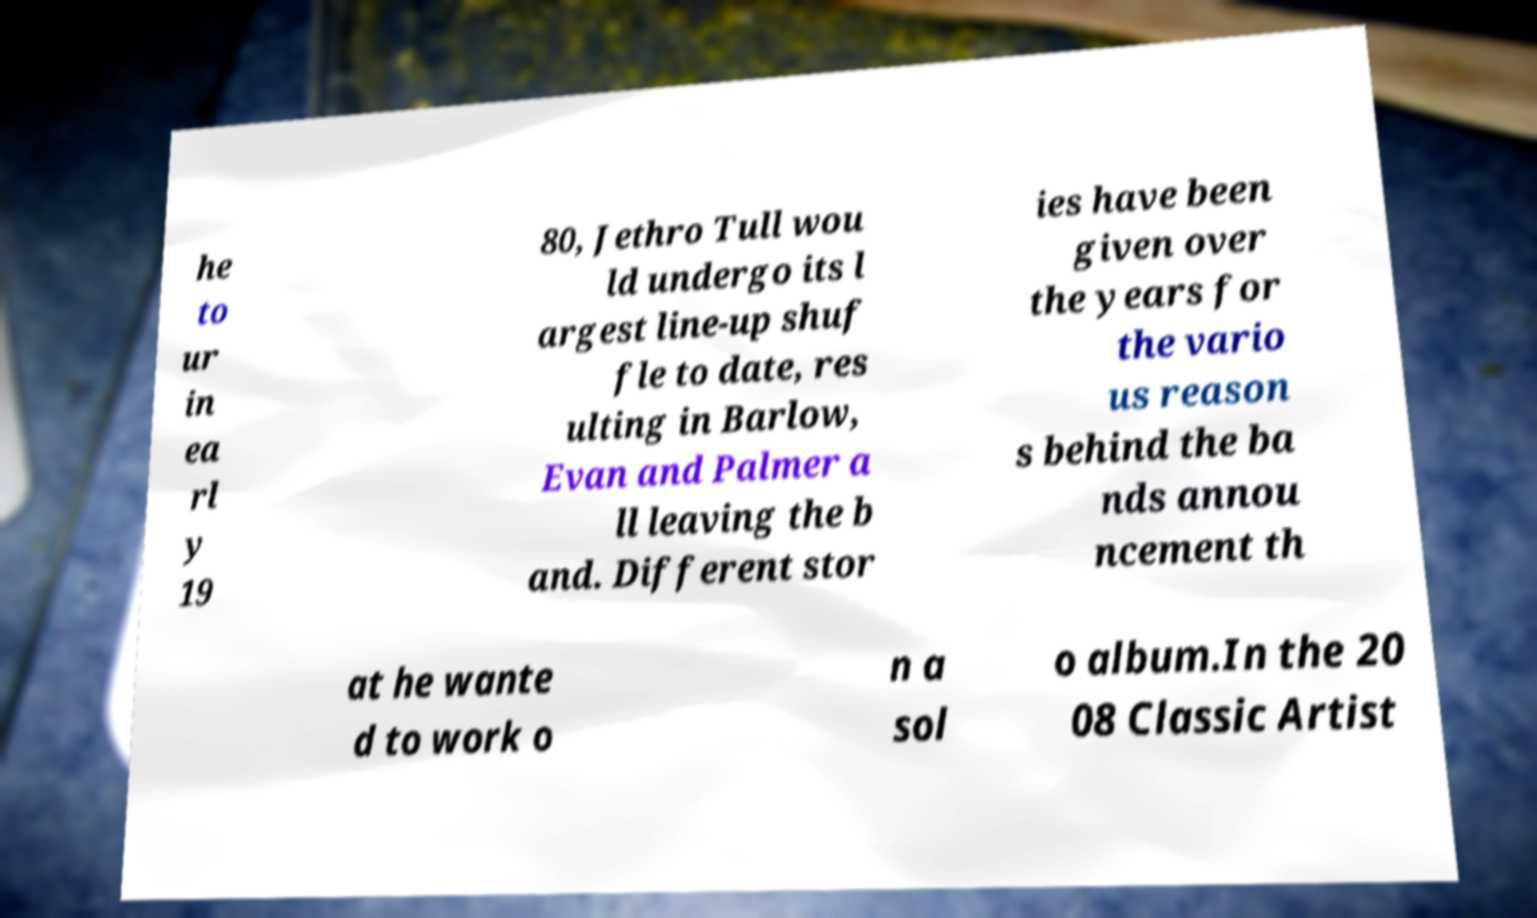Could you extract and type out the text from this image? he to ur in ea rl y 19 80, Jethro Tull wou ld undergo its l argest line-up shuf fle to date, res ulting in Barlow, Evan and Palmer a ll leaving the b and. Different stor ies have been given over the years for the vario us reason s behind the ba nds annou ncement th at he wante d to work o n a sol o album.In the 20 08 Classic Artist 